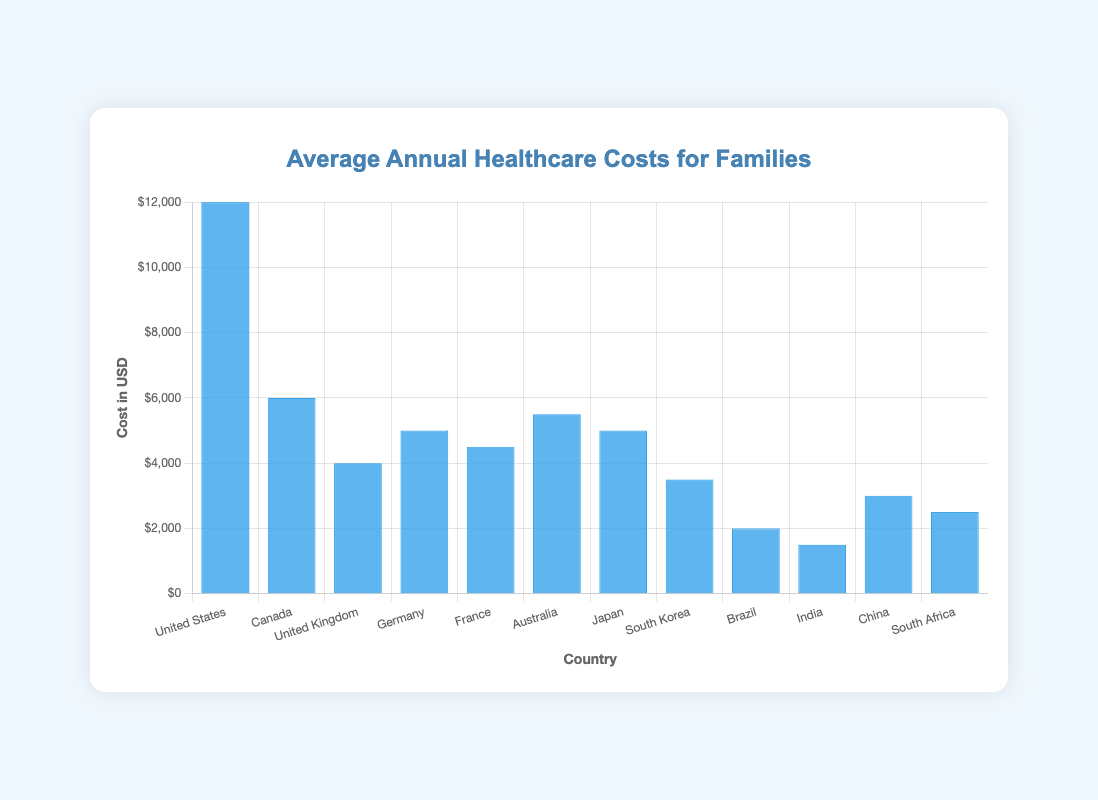Which country has the highest average annual healthcare cost? Look at the height of the bars representing each country. The bar for the United States is the tallest, indicating the highest cost.
Answer: United States What is the difference in average annual healthcare costs between Canada and the United Kingdom? Referring to the heights of the bars for Canada (6000) and the United Kingdom (4000), compute the difference: 6000 - 4000.
Answer: 2000 Which country has a lower average annual healthcare cost: Germany or Japan? Compare the heights of the bars for Germany (5000) and Japan (5000). Both bars are of equal height, showing similar costs.
Answer: Both are equal What is the combined average annual healthcare cost for families in France and Australia? Sum the values represented by the bars for France (4500) and Australia (5500): 4500 + 5500.
Answer: 10000 How does the average annual healthcare cost in South Korea compare to India? Compare the heights of the bars for South Korea (3500) and India (1500). The bar for South Korea is taller, indicating a higher cost.
Answer: South Korea is higher What is the average annual healthcare cost for the United States relative to the global average depicted? Calculate the global average by summing all the given values and dividing by the number of countries, then compare this with the cost for the United States. Sum = 12000 + 6000 + 4000 + 5000 + 4500 + 5500 + 5000 + 3500 + 2000 + 1500 + 3000 + 2500, Total = 56500, Average = 56500 / 12 ≈ 4708. The United States is higher than the global average.
Answer: United States is higher What is the visual color of the bars representing the average annual healthcare costs for the countries? Observe the color used for all the bars in the chart. They are all blue.
Answer: Blue In which country do families face the least financial burden for healthcare annually? Identify the shortest bar in the chart. The bar for India is the shortest, indicating the lowest annual cost.
Answer: India How much more do families in China spend on average annual healthcare compared to South Africa? Compare the heights of the bars for China (3000) and South Africa (2500), then find the difference: 3000 - 2500.
Answer: 500 